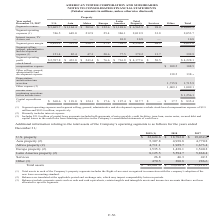According to American Tower Corporation's financial document, What did the total assets in each property segment include? the Right-of-use asset recognized in connection with the Company’s adoption of the new lease accounting standard.. The document states: "n each of the Company’s property segments includes the Right-of-use asset recognized in connection with the Company’s adoption of the new lease accoun..." Also, What do balances include? corporate assets such as cash and cash equivalents, certain tangible and intangible assets and income tax accounts that have not been allocated to specific segments.. The document states: "(3) Balances include corporate assets such as cash and cash equivalents, certain tangible and intangible assets and income tax accounts that have not ..." Also, What were the assets from Africa property in 2019? According to the financial document, 4,711.1 (in millions). The relevant text states: "Africa property (2) 4,711.1 1,929.7 1,673.4..." Also, can you calculate: What was the change in assets from U.S. property between 2018 and 2019? Based on the calculation: $22,624.6-$18,782.0, the result is 3842.6 (in millions). This is based on the information: "U.S. property $ 22,624.6 $ 18,782.0 $ 19,032.6 U.S. property $ 22,624.6 $ 18,782.0 $ 19,032.6..." The key data points involved are: 18,782.0, 22,624.6. Also, How many years did the total assets exceed $40,000 million? Based on the analysis, there are 1 instances. The counting process: 2019. Also, How many years did other assets exceed $300 million? Based on the analysis, there are 1 instances. The counting process: 2019. 